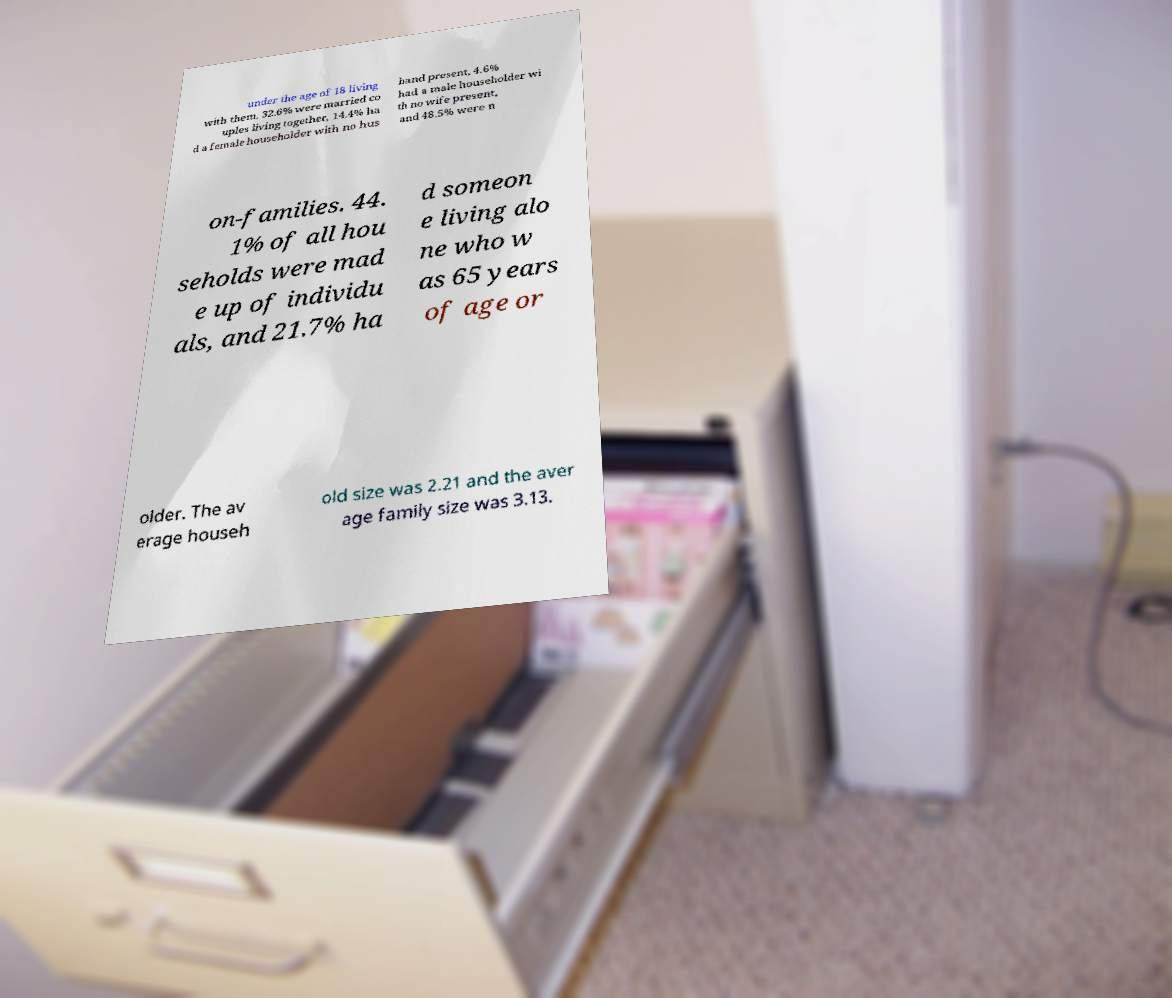Could you assist in decoding the text presented in this image and type it out clearly? under the age of 18 living with them, 32.6% were married co uples living together, 14.4% ha d a female householder with no hus band present, 4.6% had a male householder wi th no wife present, and 48.5% were n on-families. 44. 1% of all hou seholds were mad e up of individu als, and 21.7% ha d someon e living alo ne who w as 65 years of age or older. The av erage househ old size was 2.21 and the aver age family size was 3.13. 